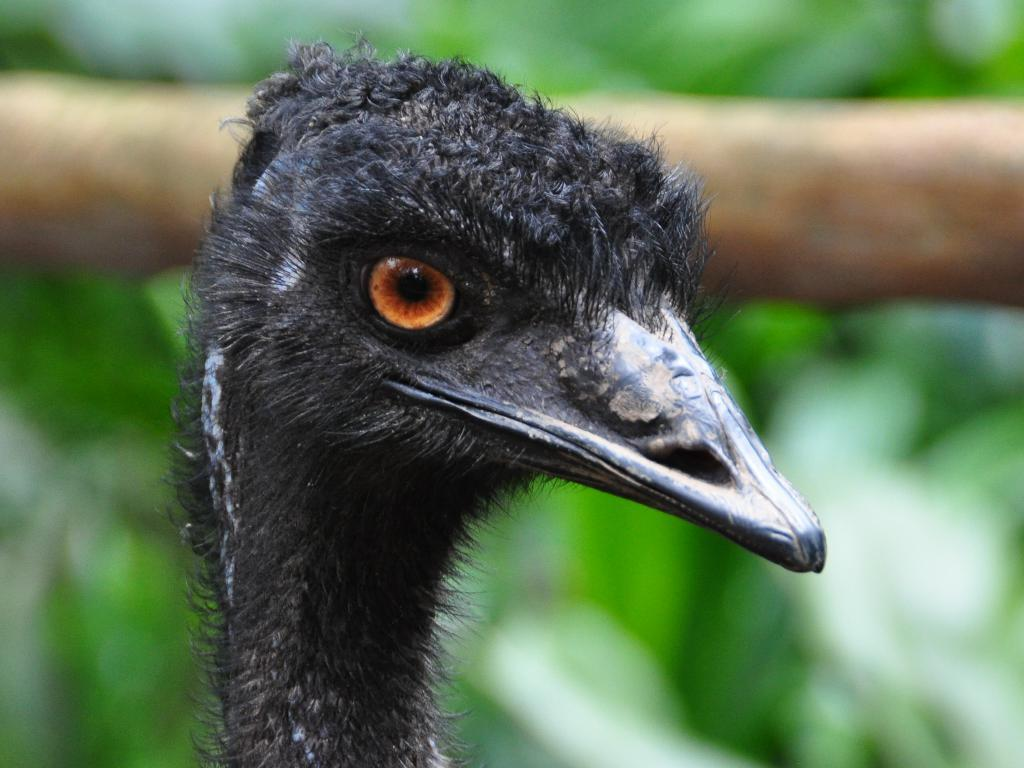What is the main subject of the picture? The main subject of the picture is a bird. Where is the bird located in the image? The bird is in the middle of the image. What color is the bird? The bird is black in color. How many fingers can be seen holding the bird in the image? There are no fingers visible in the image, as the bird is not being held by any hands. 